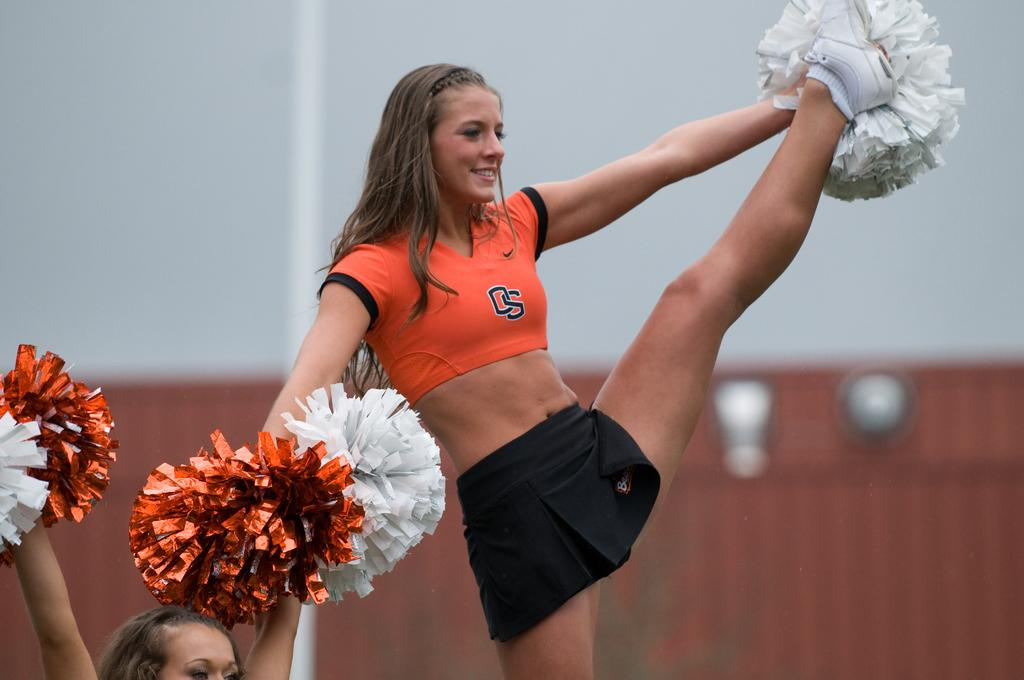Provide a one-sentence caption for the provided image. A cheerleader in an orange top bearing the initials OS kicks her left leg high into the air whilst holding pom poms. 